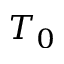Convert formula to latex. <formula><loc_0><loc_0><loc_500><loc_500>T _ { 0 }</formula> 